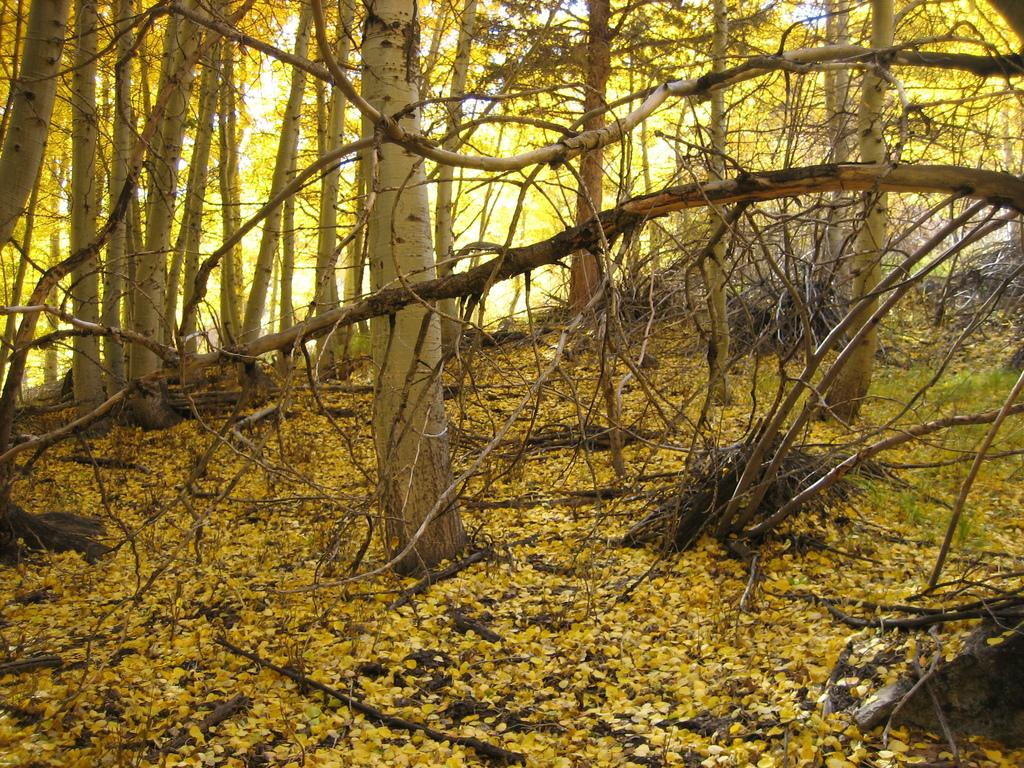What type of environment is shown in the image? The image depicts a forest area. What can be observed on the forest floor? The forest floor is covered in yellow leaves. How many trees are visible in the image? There are many trees in the forest. What type of leather chairs can be seen in the image? There are no chairs, leather or otherwise, present in the image. The image depicts a forest area with trees and a yellow leaf-covered forest floor. 